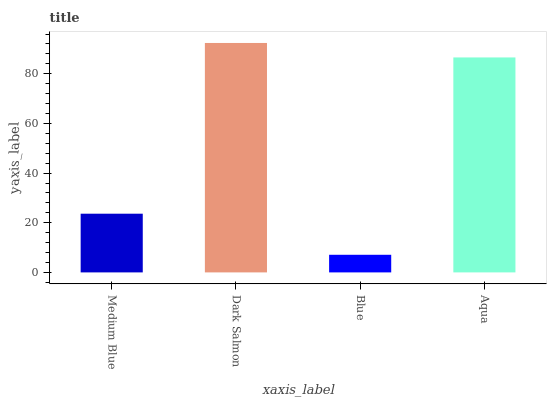Is Blue the minimum?
Answer yes or no. Yes. Is Dark Salmon the maximum?
Answer yes or no. Yes. Is Dark Salmon the minimum?
Answer yes or no. No. Is Blue the maximum?
Answer yes or no. No. Is Dark Salmon greater than Blue?
Answer yes or no. Yes. Is Blue less than Dark Salmon?
Answer yes or no. Yes. Is Blue greater than Dark Salmon?
Answer yes or no. No. Is Dark Salmon less than Blue?
Answer yes or no. No. Is Aqua the high median?
Answer yes or no. Yes. Is Medium Blue the low median?
Answer yes or no. Yes. Is Blue the high median?
Answer yes or no. No. Is Dark Salmon the low median?
Answer yes or no. No. 